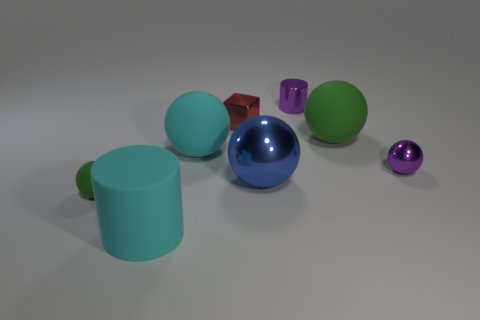There is a ball that is both to the right of the large blue metallic object and behind the small purple ball; what is it made of?
Provide a short and direct response. Rubber. The tiny matte thing is what color?
Your response must be concise. Green. What number of large green matte objects have the same shape as the small green rubber thing?
Make the answer very short. 1. Are the cylinder on the left side of the cyan matte sphere and the green thing that is behind the big cyan rubber ball made of the same material?
Your response must be concise. Yes. There is a green rubber thing right of the green matte ball that is left of the big cyan cylinder; how big is it?
Your answer should be compact. Large. Is there anything else that has the same size as the shiny cube?
Keep it short and to the point. Yes. What material is the other purple object that is the same shape as the big metallic thing?
Offer a very short reply. Metal. Is the shape of the tiny purple thing that is right of the tiny purple metallic cylinder the same as the green object that is to the left of the metallic block?
Ensure brevity in your answer.  Yes. Are there more red things than green rubber blocks?
Your answer should be very brief. Yes. The red object has what size?
Ensure brevity in your answer.  Small. 